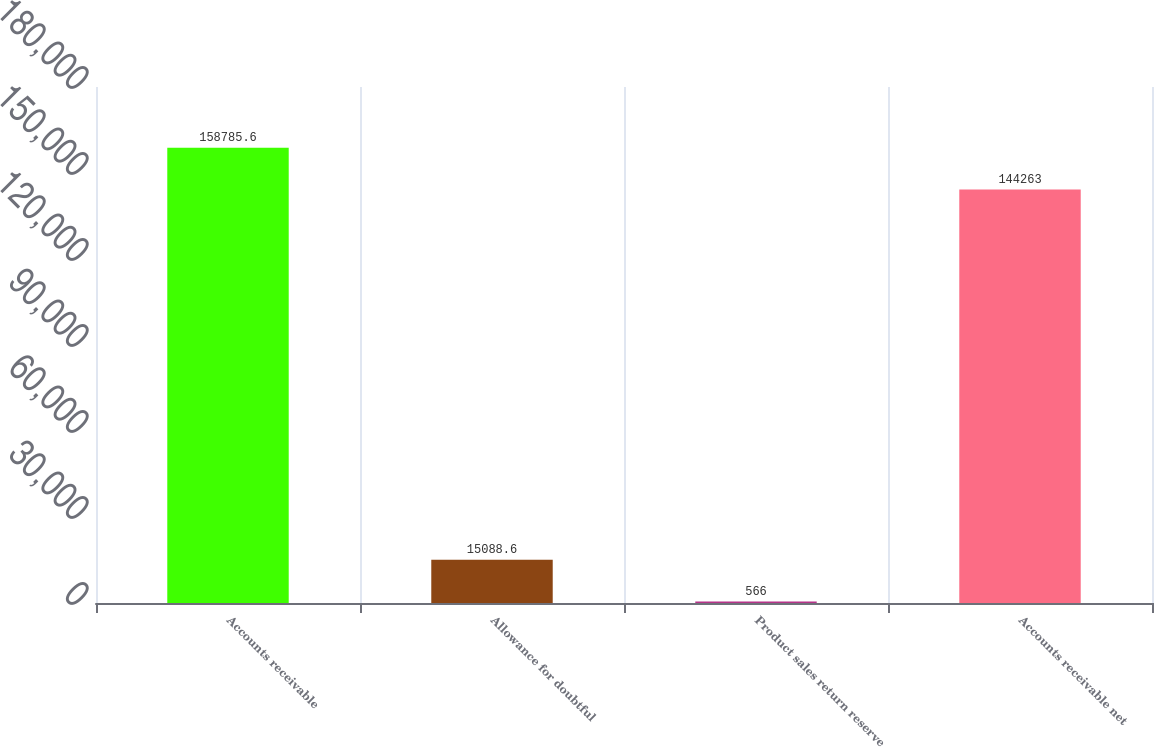<chart> <loc_0><loc_0><loc_500><loc_500><bar_chart><fcel>Accounts receivable<fcel>Allowance for doubtful<fcel>Product sales return reserve<fcel>Accounts receivable net<nl><fcel>158786<fcel>15088.6<fcel>566<fcel>144263<nl></chart> 